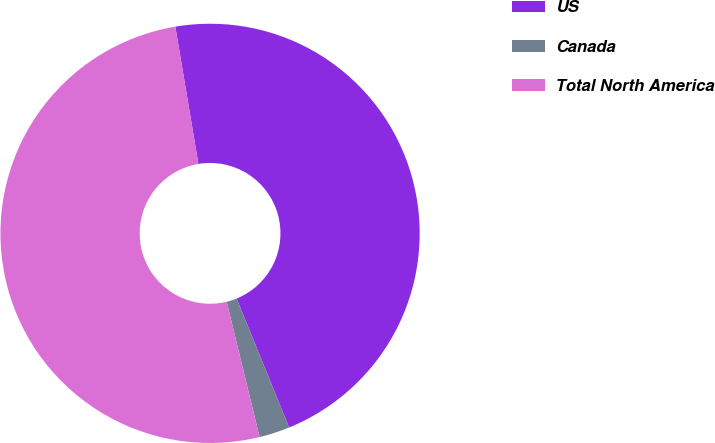Convert chart to OTSL. <chart><loc_0><loc_0><loc_500><loc_500><pie_chart><fcel>US<fcel>Canada<fcel>Total North America<nl><fcel>46.49%<fcel>2.36%<fcel>51.14%<nl></chart> 